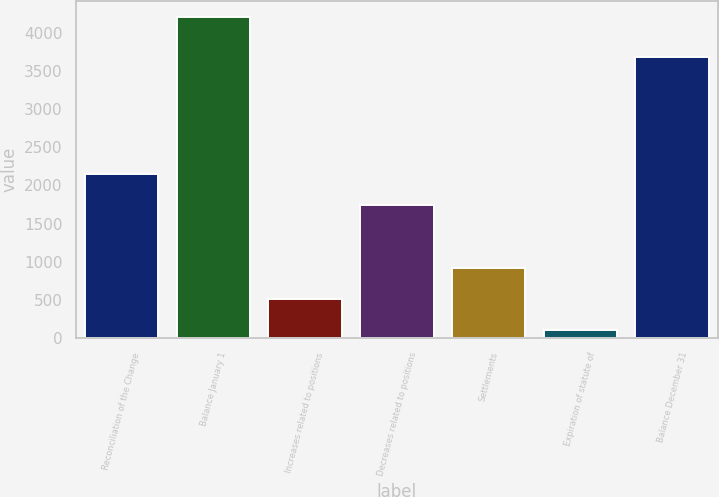<chart> <loc_0><loc_0><loc_500><loc_500><bar_chart><fcel>Reconciliation of the Change<fcel>Balance January 1<fcel>Increases related to positions<fcel>Decreases related to positions<fcel>Settlements<fcel>Expiration of statute of<fcel>Balance December 31<nl><fcel>2153.5<fcel>4203<fcel>513.9<fcel>1743.6<fcel>923.8<fcel>104<fcel>3677<nl></chart> 